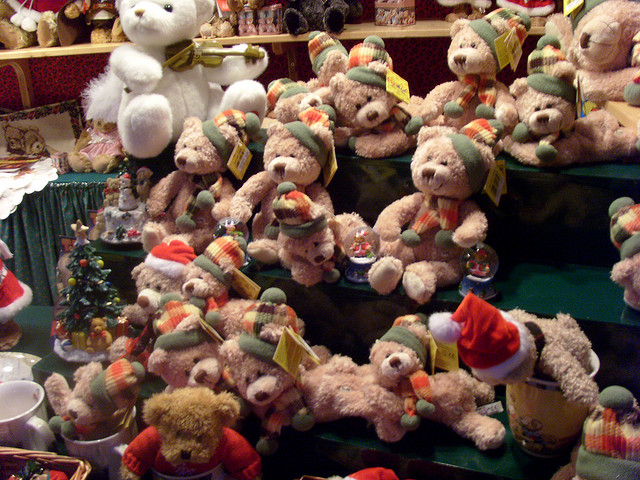<image>Where are these dolls sold? I don't know where these dolls are sold. It could be in a general store, a toy store, a department store, or a holiday store. Where are these dolls sold? I don't know where these dolls are sold. They can be found in a store or a toy store. 